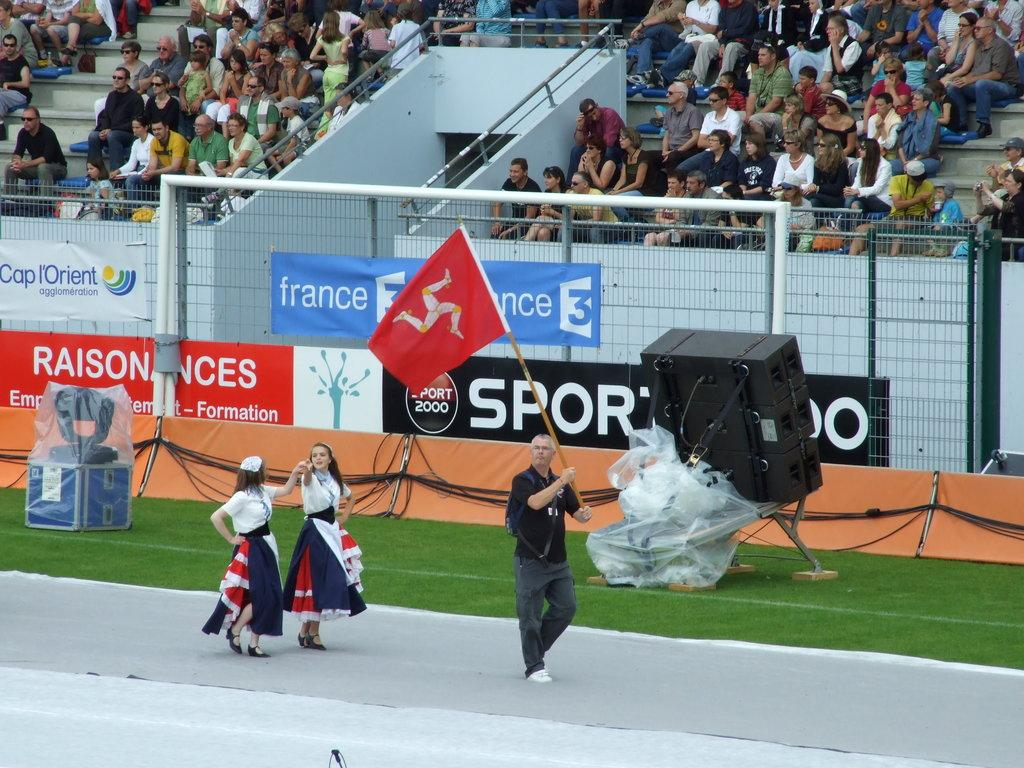Provide a one-sentence caption for the provided image. A man holding a red flag in stadium in France. 